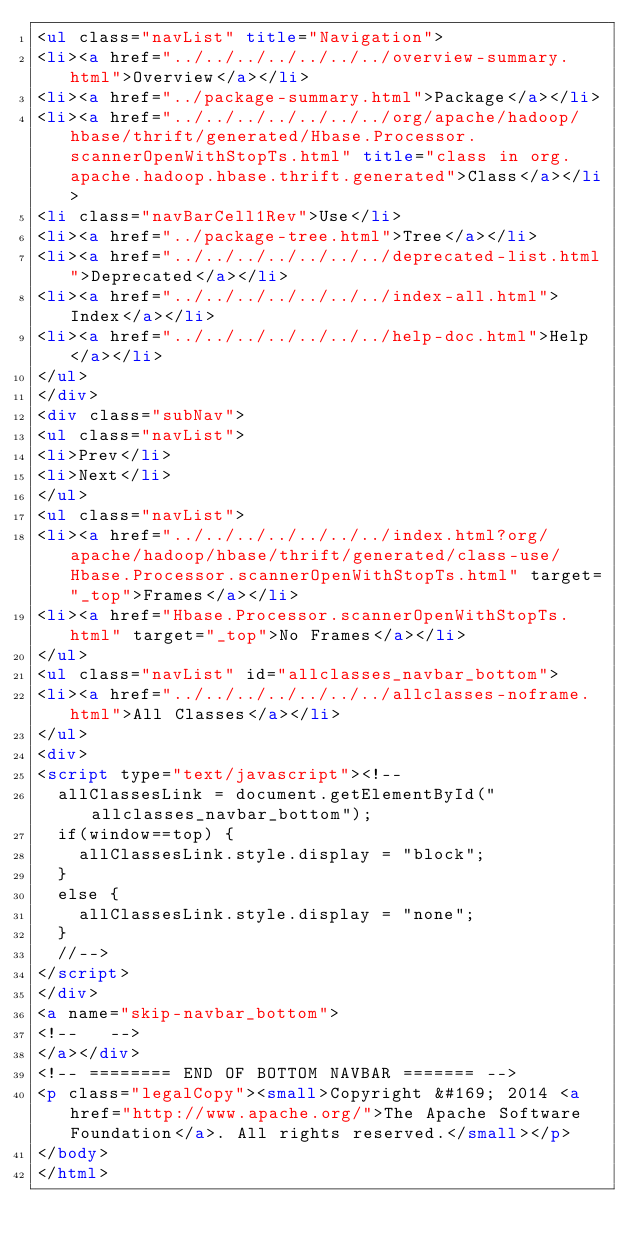<code> <loc_0><loc_0><loc_500><loc_500><_HTML_><ul class="navList" title="Navigation">
<li><a href="../../../../../../../overview-summary.html">Overview</a></li>
<li><a href="../package-summary.html">Package</a></li>
<li><a href="../../../../../../../org/apache/hadoop/hbase/thrift/generated/Hbase.Processor.scannerOpenWithStopTs.html" title="class in org.apache.hadoop.hbase.thrift.generated">Class</a></li>
<li class="navBarCell1Rev">Use</li>
<li><a href="../package-tree.html">Tree</a></li>
<li><a href="../../../../../../../deprecated-list.html">Deprecated</a></li>
<li><a href="../../../../../../../index-all.html">Index</a></li>
<li><a href="../../../../../../../help-doc.html">Help</a></li>
</ul>
</div>
<div class="subNav">
<ul class="navList">
<li>Prev</li>
<li>Next</li>
</ul>
<ul class="navList">
<li><a href="../../../../../../../index.html?org/apache/hadoop/hbase/thrift/generated/class-use/Hbase.Processor.scannerOpenWithStopTs.html" target="_top">Frames</a></li>
<li><a href="Hbase.Processor.scannerOpenWithStopTs.html" target="_top">No Frames</a></li>
</ul>
<ul class="navList" id="allclasses_navbar_bottom">
<li><a href="../../../../../../../allclasses-noframe.html">All Classes</a></li>
</ul>
<div>
<script type="text/javascript"><!--
  allClassesLink = document.getElementById("allclasses_navbar_bottom");
  if(window==top) {
    allClassesLink.style.display = "block";
  }
  else {
    allClassesLink.style.display = "none";
  }
  //-->
</script>
</div>
<a name="skip-navbar_bottom">
<!--   -->
</a></div>
<!-- ======== END OF BOTTOM NAVBAR ======= -->
<p class="legalCopy"><small>Copyright &#169; 2014 <a href="http://www.apache.org/">The Apache Software Foundation</a>. All rights reserved.</small></p>
</body>
</html>
</code> 